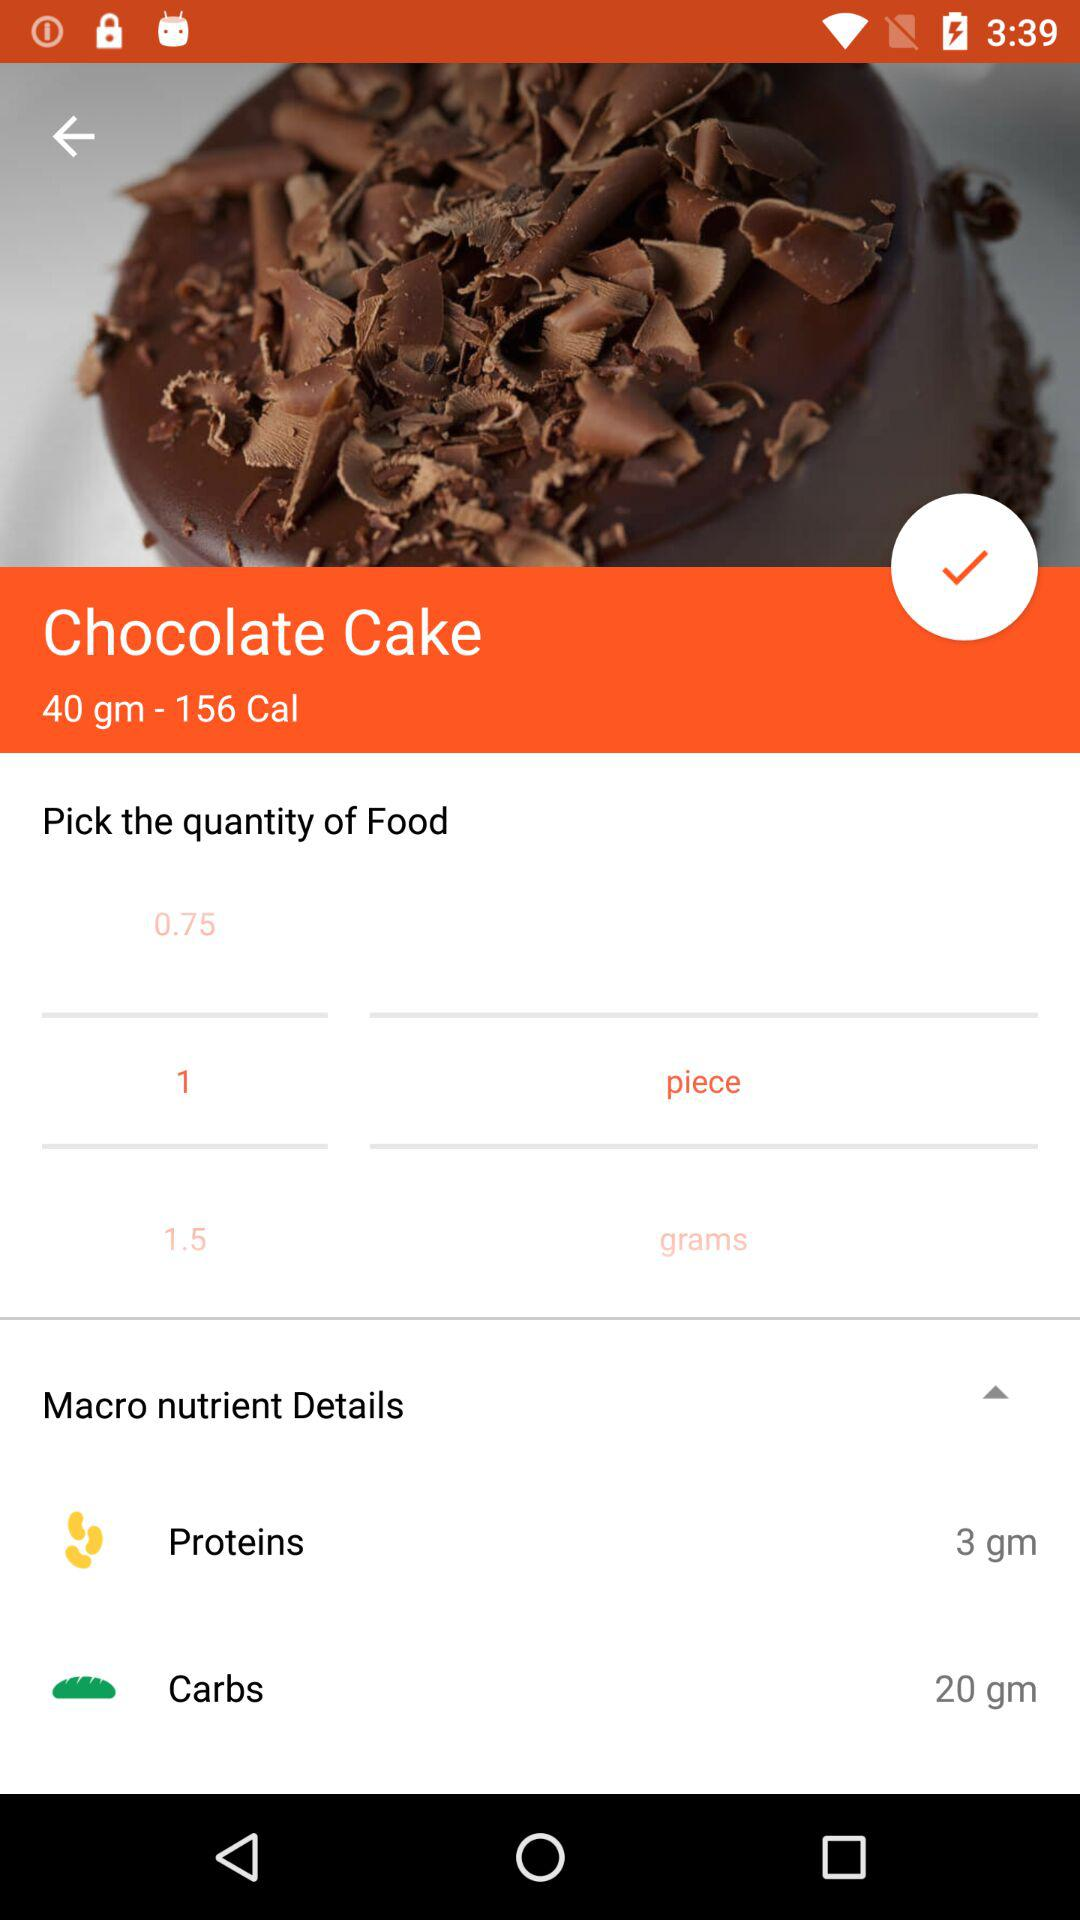How many more grams of carbs are there than proteins in the chocolate cake?
Answer the question using a single word or phrase. 17 